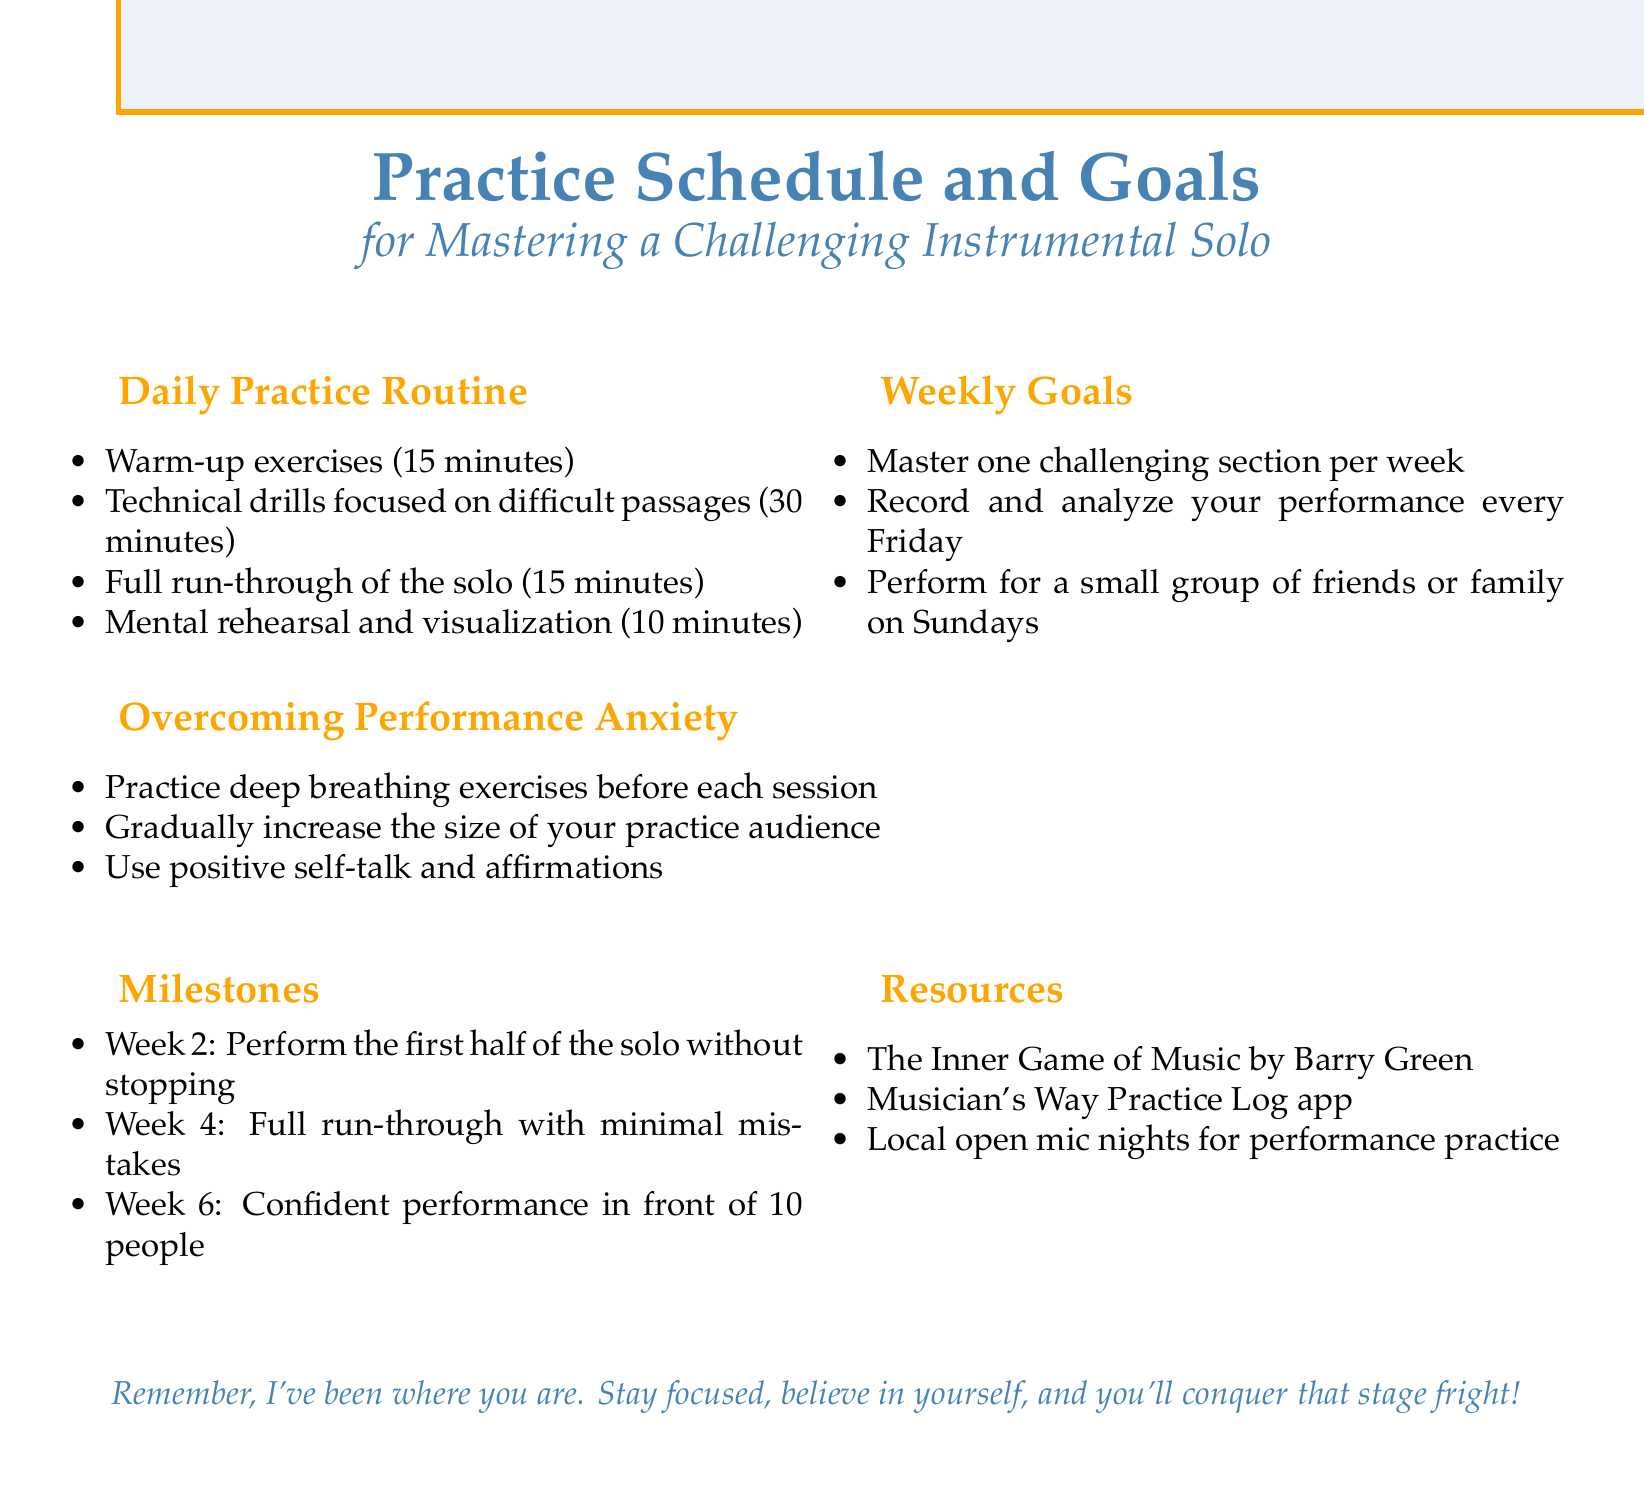What is the duration of warm-up exercises? The document states that warm-up exercises take 15 minutes in the daily practice routine.
Answer: 15 minutes What is the focus of the technical drills? The technical drills are aimed at mastering difficult passages as part of the daily practice routine.
Answer: Difficult passages How often should one record their performance? Weekly goals indicate that one should record and analyze their performance every Friday.
Answer: Every Friday What milestone should be achieved by week 2? The document specifies that the goal for week 2 is to perform the first half of the solo without stopping.
Answer: First half of the solo without stopping Which resource is suggested for performance practice? The document includes local open mic nights as a recommended resource for performance practice.
Answer: Local open mic nights What kind of exercises should be practiced to overcome performance anxiety? The document advises practicing deep breathing exercises before each session to help overcome performance anxiety.
Answer: Deep breathing exercises How many people should one aim to perform in front of by week 6? The milestones state that by week 6, one should confidently perform in front of 10 people.
Answer: 10 people What is one way to gradually increase the size of the practice audience? The document suggests gradually increasing the size of your practice audience as a technique to reduce performance anxiety.
Answer: Gradually increase audience size What is the primary goal for the weekly practice scheme? The weekly goals emphasize mastering one challenging section each week.
Answer: Master one challenging section per week 